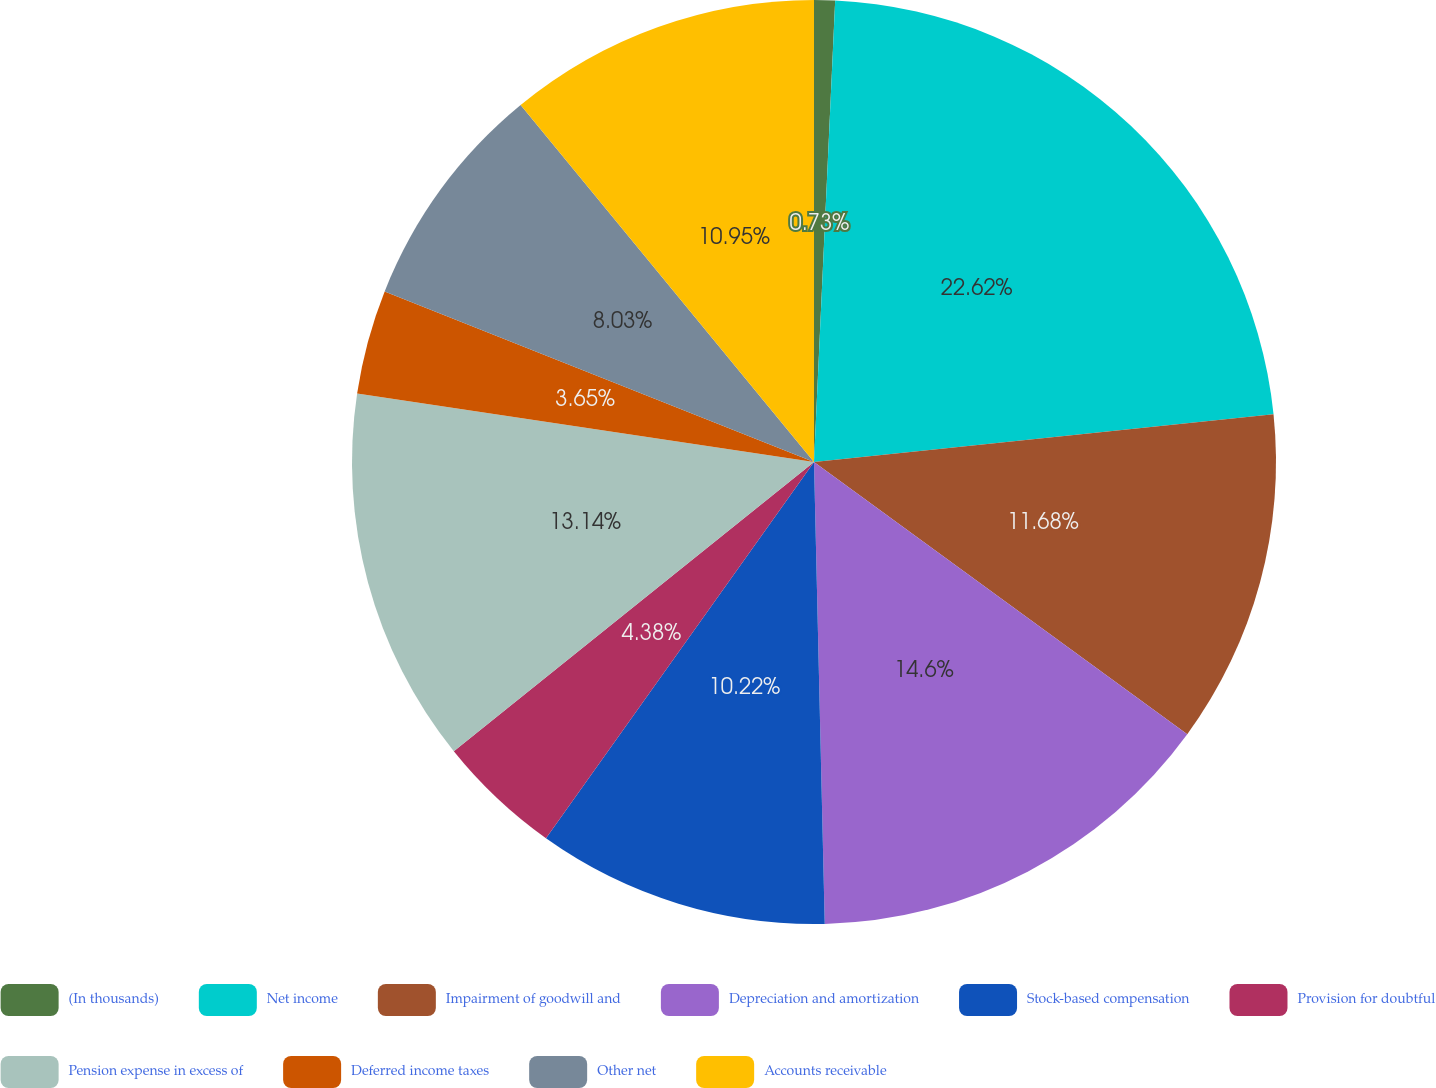<chart> <loc_0><loc_0><loc_500><loc_500><pie_chart><fcel>(In thousands)<fcel>Net income<fcel>Impairment of goodwill and<fcel>Depreciation and amortization<fcel>Stock-based compensation<fcel>Provision for doubtful<fcel>Pension expense in excess of<fcel>Deferred income taxes<fcel>Other net<fcel>Accounts receivable<nl><fcel>0.73%<fcel>22.62%<fcel>11.68%<fcel>14.6%<fcel>10.22%<fcel>4.38%<fcel>13.14%<fcel>3.65%<fcel>8.03%<fcel>10.95%<nl></chart> 